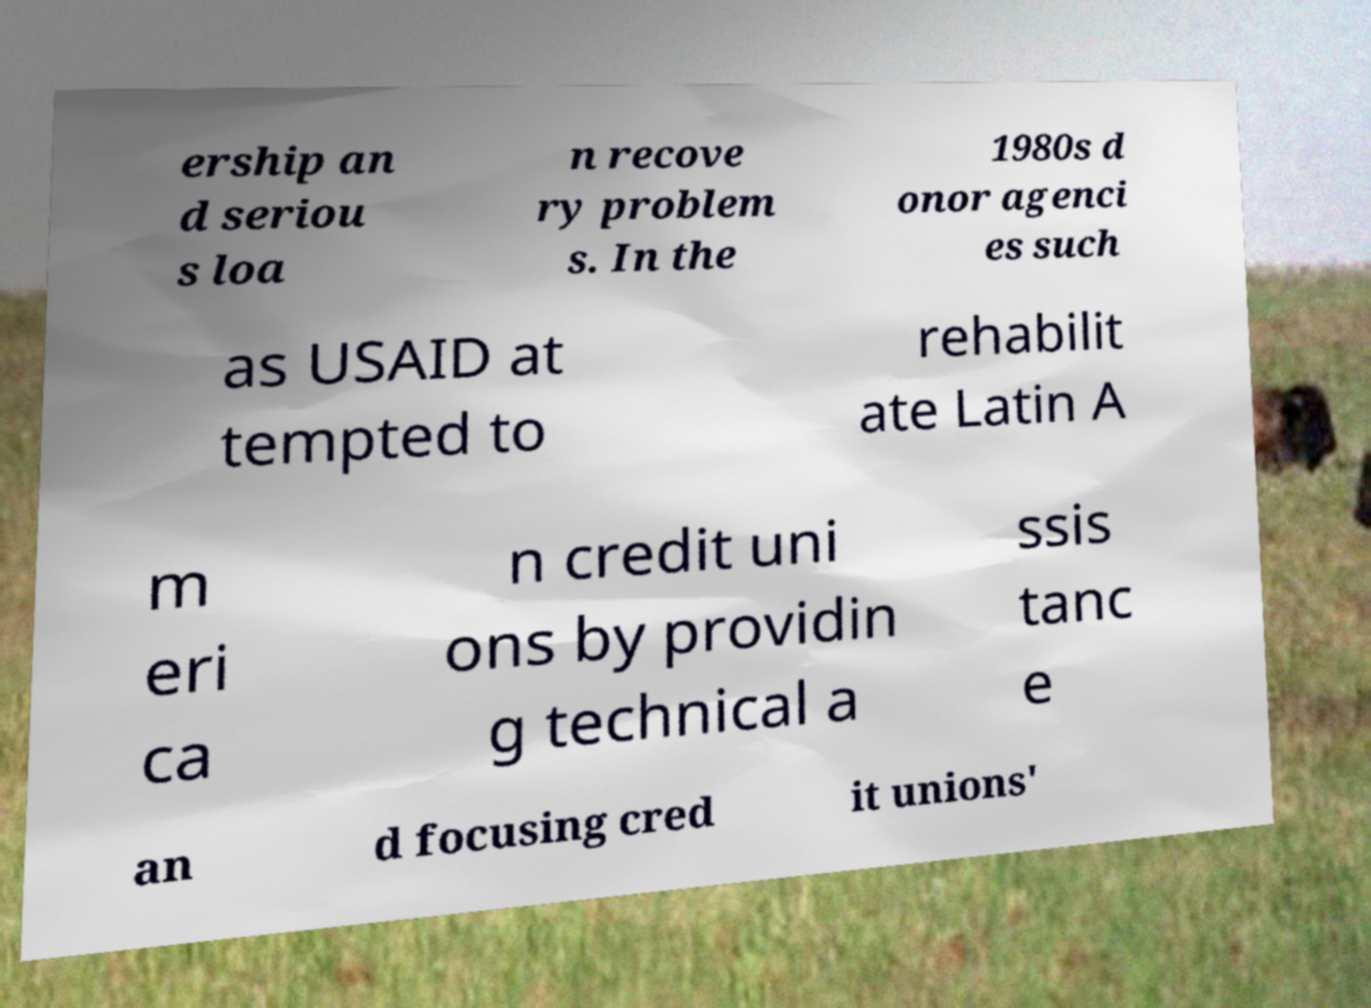I need the written content from this picture converted into text. Can you do that? ership an d seriou s loa n recove ry problem s. In the 1980s d onor agenci es such as USAID at tempted to rehabilit ate Latin A m eri ca n credit uni ons by providin g technical a ssis tanc e an d focusing cred it unions' 